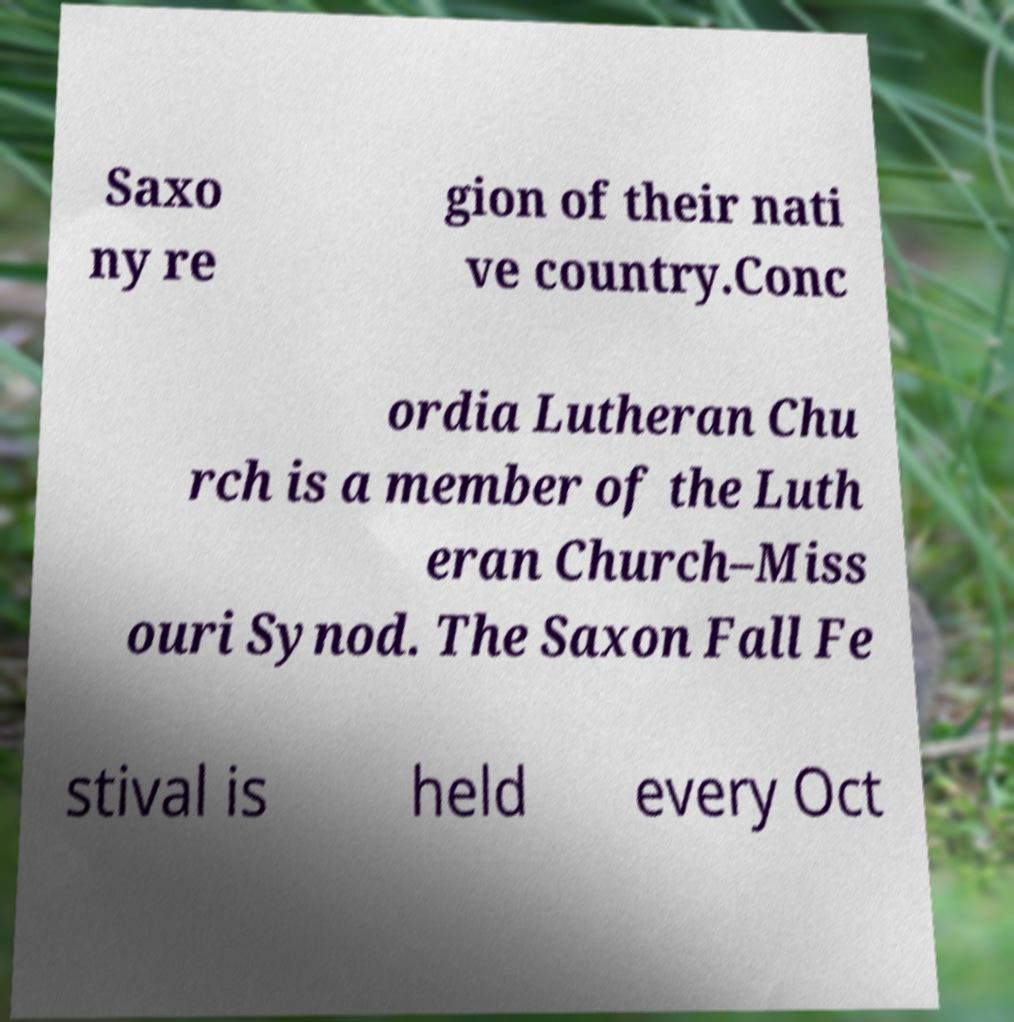Please identify and transcribe the text found in this image. Saxo ny re gion of their nati ve country.Conc ordia Lutheran Chu rch is a member of the Luth eran Church–Miss ouri Synod. The Saxon Fall Fe stival is held every Oct 